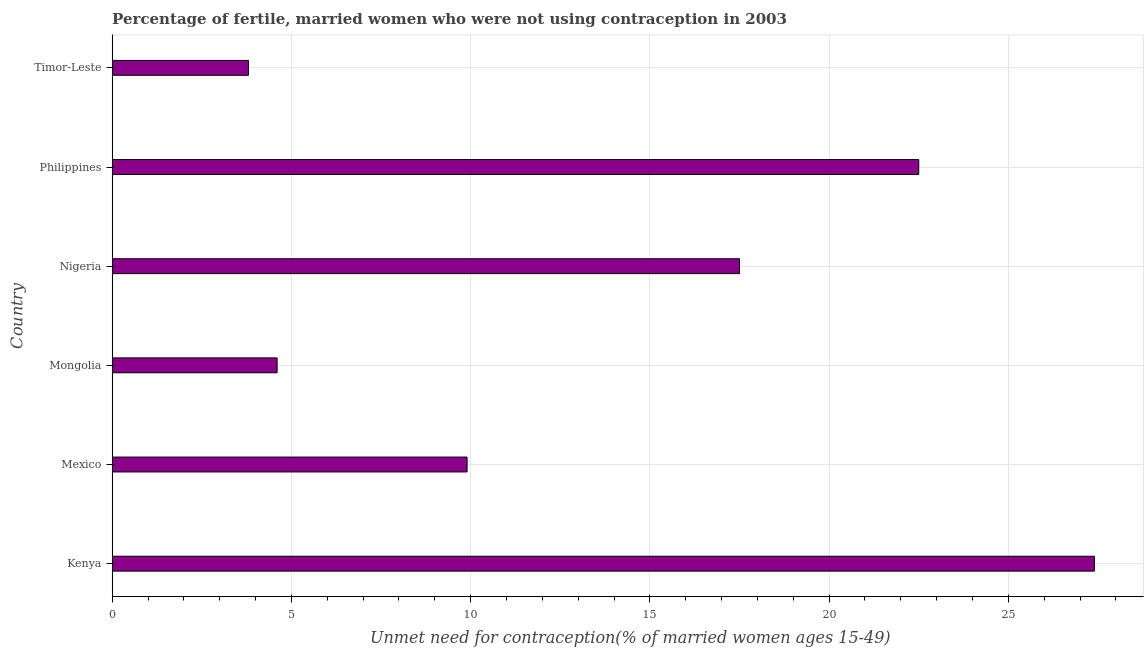Does the graph contain any zero values?
Make the answer very short. No. What is the title of the graph?
Your answer should be very brief. Percentage of fertile, married women who were not using contraception in 2003. What is the label or title of the X-axis?
Make the answer very short.  Unmet need for contraception(% of married women ages 15-49). What is the number of married women who are not using contraception in Mongolia?
Make the answer very short. 4.6. Across all countries, what is the maximum number of married women who are not using contraception?
Ensure brevity in your answer.  27.4. Across all countries, what is the minimum number of married women who are not using contraception?
Your answer should be compact. 3.8. In which country was the number of married women who are not using contraception maximum?
Your answer should be compact. Kenya. In which country was the number of married women who are not using contraception minimum?
Provide a short and direct response. Timor-Leste. What is the sum of the number of married women who are not using contraception?
Your response must be concise. 85.7. What is the difference between the number of married women who are not using contraception in Kenya and Mexico?
Your response must be concise. 17.5. What is the average number of married women who are not using contraception per country?
Offer a very short reply. 14.28. In how many countries, is the number of married women who are not using contraception greater than 27 %?
Give a very brief answer. 1. What is the ratio of the number of married women who are not using contraception in Philippines to that in Timor-Leste?
Offer a very short reply. 5.92. Is the number of married women who are not using contraception in Mexico less than that in Philippines?
Offer a terse response. Yes. Is the difference between the number of married women who are not using contraception in Mexico and Timor-Leste greater than the difference between any two countries?
Keep it short and to the point. No. What is the difference between the highest and the second highest number of married women who are not using contraception?
Your answer should be very brief. 4.9. What is the difference between the highest and the lowest number of married women who are not using contraception?
Provide a succinct answer. 23.6. How many bars are there?
Keep it short and to the point. 6. Are all the bars in the graph horizontal?
Ensure brevity in your answer.  Yes. How many countries are there in the graph?
Ensure brevity in your answer.  6. Are the values on the major ticks of X-axis written in scientific E-notation?
Your answer should be compact. No. What is the  Unmet need for contraception(% of married women ages 15-49) of Kenya?
Give a very brief answer. 27.4. What is the  Unmet need for contraception(% of married women ages 15-49) in Mongolia?
Your answer should be very brief. 4.6. What is the  Unmet need for contraception(% of married women ages 15-49) in Nigeria?
Provide a short and direct response. 17.5. What is the difference between the  Unmet need for contraception(% of married women ages 15-49) in Kenya and Mongolia?
Your response must be concise. 22.8. What is the difference between the  Unmet need for contraception(% of married women ages 15-49) in Kenya and Nigeria?
Offer a very short reply. 9.9. What is the difference between the  Unmet need for contraception(% of married women ages 15-49) in Kenya and Timor-Leste?
Your answer should be very brief. 23.6. What is the difference between the  Unmet need for contraception(% of married women ages 15-49) in Mexico and Philippines?
Make the answer very short. -12.6. What is the difference between the  Unmet need for contraception(% of married women ages 15-49) in Mexico and Timor-Leste?
Provide a short and direct response. 6.1. What is the difference between the  Unmet need for contraception(% of married women ages 15-49) in Mongolia and Nigeria?
Your answer should be very brief. -12.9. What is the difference between the  Unmet need for contraception(% of married women ages 15-49) in Mongolia and Philippines?
Your response must be concise. -17.9. What is the difference between the  Unmet need for contraception(% of married women ages 15-49) in Nigeria and Philippines?
Keep it short and to the point. -5. What is the difference between the  Unmet need for contraception(% of married women ages 15-49) in Philippines and Timor-Leste?
Keep it short and to the point. 18.7. What is the ratio of the  Unmet need for contraception(% of married women ages 15-49) in Kenya to that in Mexico?
Provide a succinct answer. 2.77. What is the ratio of the  Unmet need for contraception(% of married women ages 15-49) in Kenya to that in Mongolia?
Ensure brevity in your answer.  5.96. What is the ratio of the  Unmet need for contraception(% of married women ages 15-49) in Kenya to that in Nigeria?
Ensure brevity in your answer.  1.57. What is the ratio of the  Unmet need for contraception(% of married women ages 15-49) in Kenya to that in Philippines?
Your response must be concise. 1.22. What is the ratio of the  Unmet need for contraception(% of married women ages 15-49) in Kenya to that in Timor-Leste?
Provide a succinct answer. 7.21. What is the ratio of the  Unmet need for contraception(% of married women ages 15-49) in Mexico to that in Mongolia?
Offer a very short reply. 2.15. What is the ratio of the  Unmet need for contraception(% of married women ages 15-49) in Mexico to that in Nigeria?
Make the answer very short. 0.57. What is the ratio of the  Unmet need for contraception(% of married women ages 15-49) in Mexico to that in Philippines?
Make the answer very short. 0.44. What is the ratio of the  Unmet need for contraception(% of married women ages 15-49) in Mexico to that in Timor-Leste?
Give a very brief answer. 2.6. What is the ratio of the  Unmet need for contraception(% of married women ages 15-49) in Mongolia to that in Nigeria?
Offer a very short reply. 0.26. What is the ratio of the  Unmet need for contraception(% of married women ages 15-49) in Mongolia to that in Philippines?
Make the answer very short. 0.2. What is the ratio of the  Unmet need for contraception(% of married women ages 15-49) in Mongolia to that in Timor-Leste?
Your answer should be compact. 1.21. What is the ratio of the  Unmet need for contraception(% of married women ages 15-49) in Nigeria to that in Philippines?
Give a very brief answer. 0.78. What is the ratio of the  Unmet need for contraception(% of married women ages 15-49) in Nigeria to that in Timor-Leste?
Your response must be concise. 4.61. What is the ratio of the  Unmet need for contraception(% of married women ages 15-49) in Philippines to that in Timor-Leste?
Your response must be concise. 5.92. 